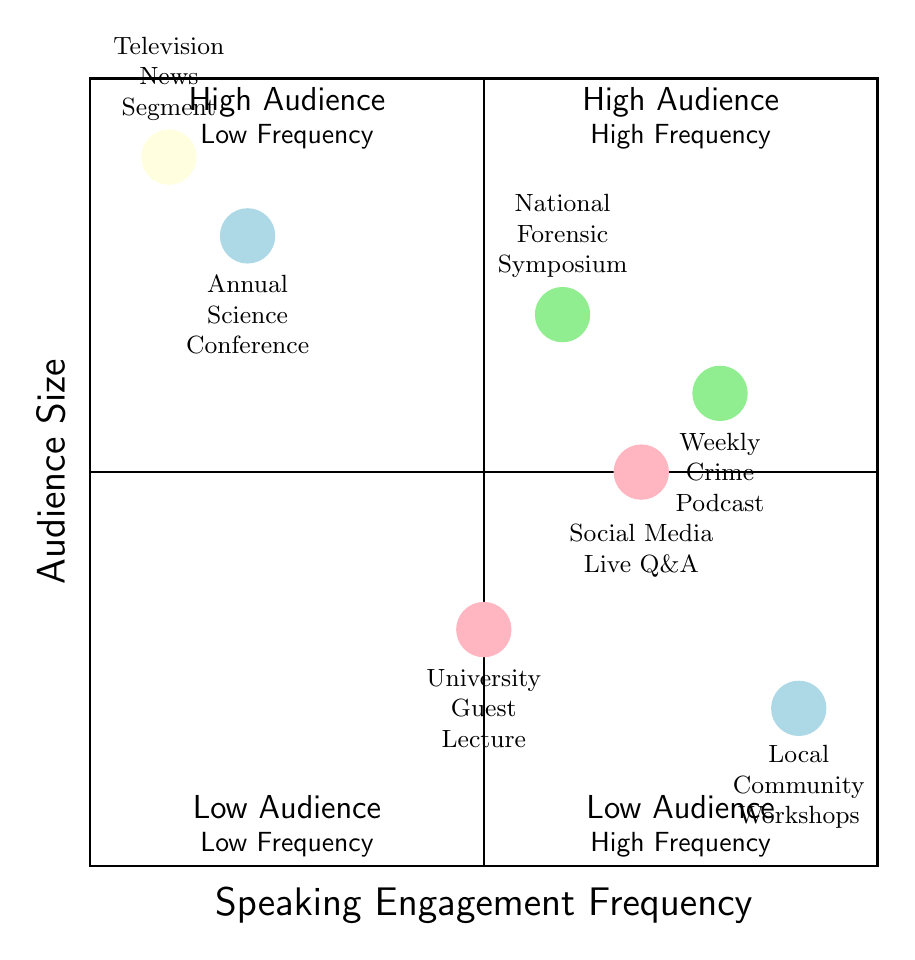What is the audience size for the Annual Science Conference? The diagram indicates that the Annual Science Conference falls in the quadrant of High Audience and Low Frequency. According to the data provided, the audience size is classified as High.
Answer: High Which engagement has the lowest audience size? The diagram shows the University Guest Lecture and Local Community Workshops in the quadrant of Low Audience and High Frequency. Of these, the University Guest Lecture is specifically identified as having Low audience size.
Answer: Low How many engagements fall in the Low Frequency, High Audience quadrant? By examining the diagram, we can see two engagements positioned in this quadrant: the Annual Science Conference and Television News Segment. Therefore, the total count is two.
Answer: 2 What two engagements have High Frequency and Medium Audience size? Looking directly at the corresponding quadrant for High Frequency and Medium Audience size, we can identify the Weekly Crime Podcast and Social Media Live Q&A. Both engagements fit the criteria described.
Answer: Weekly Crime Podcast, Social Media Live Q&A What is the audience size of the National Forensic Symposium? The data shows that the National Forensic Symposium is located in the quadrant characterized as High Audience and Medium Frequency on the diagram. According to the information, its audience size is High.
Answer: High Which engagement has High Frequency but Low Audience size? According to the diagram, the Local Community Workshops are categorized in the Low Audience and High Frequency quadrant. This indicates that they have High Frequency and Low Audience size.
Answer: Local Community Workshops 